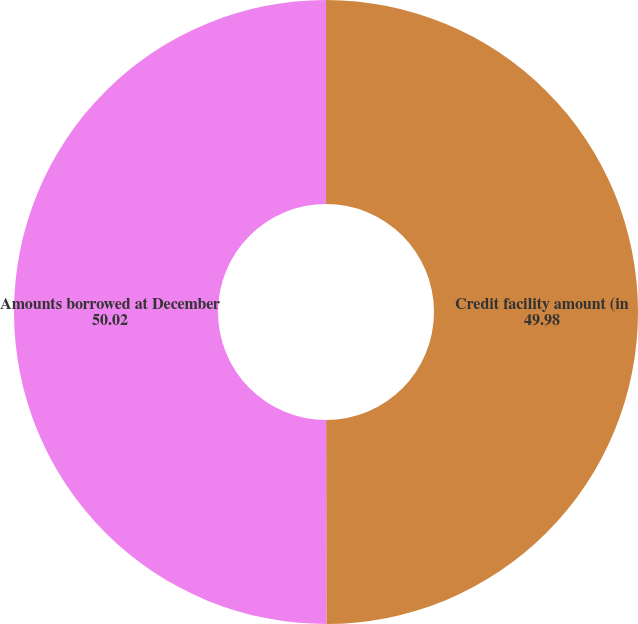Convert chart. <chart><loc_0><loc_0><loc_500><loc_500><pie_chart><fcel>Credit facility amount (in<fcel>Amounts borrowed at December<nl><fcel>49.98%<fcel>50.02%<nl></chart> 